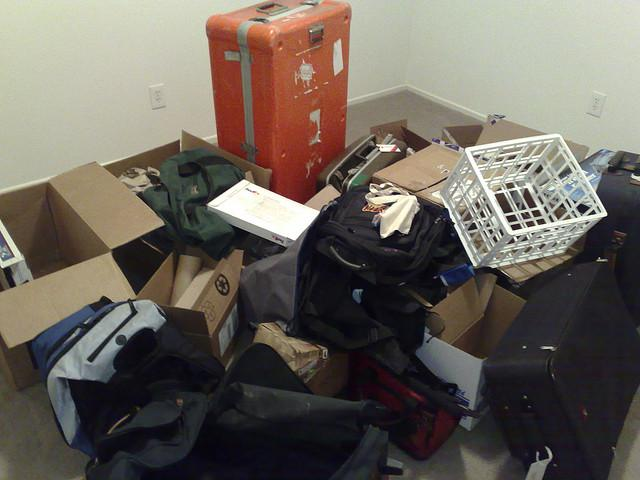What is someone who collects huge amounts of rubbish called? hoarder 